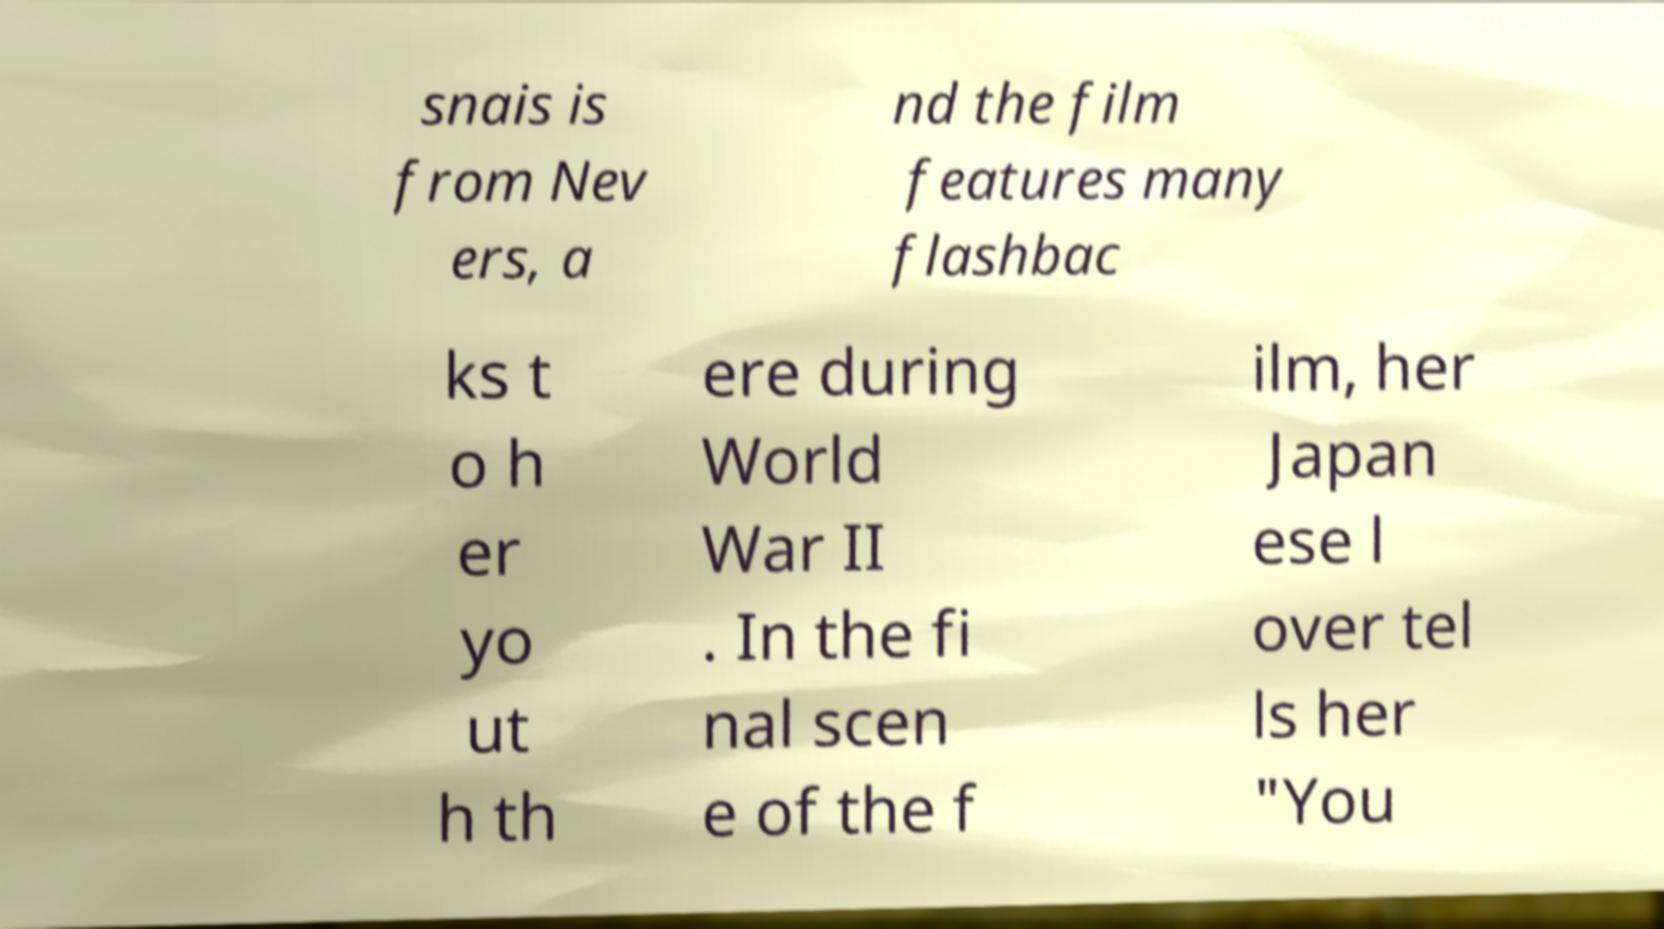Could you assist in decoding the text presented in this image and type it out clearly? snais is from Nev ers, a nd the film features many flashbac ks t o h er yo ut h th ere during World War II . In the fi nal scen e of the f ilm, her Japan ese l over tel ls her "You 